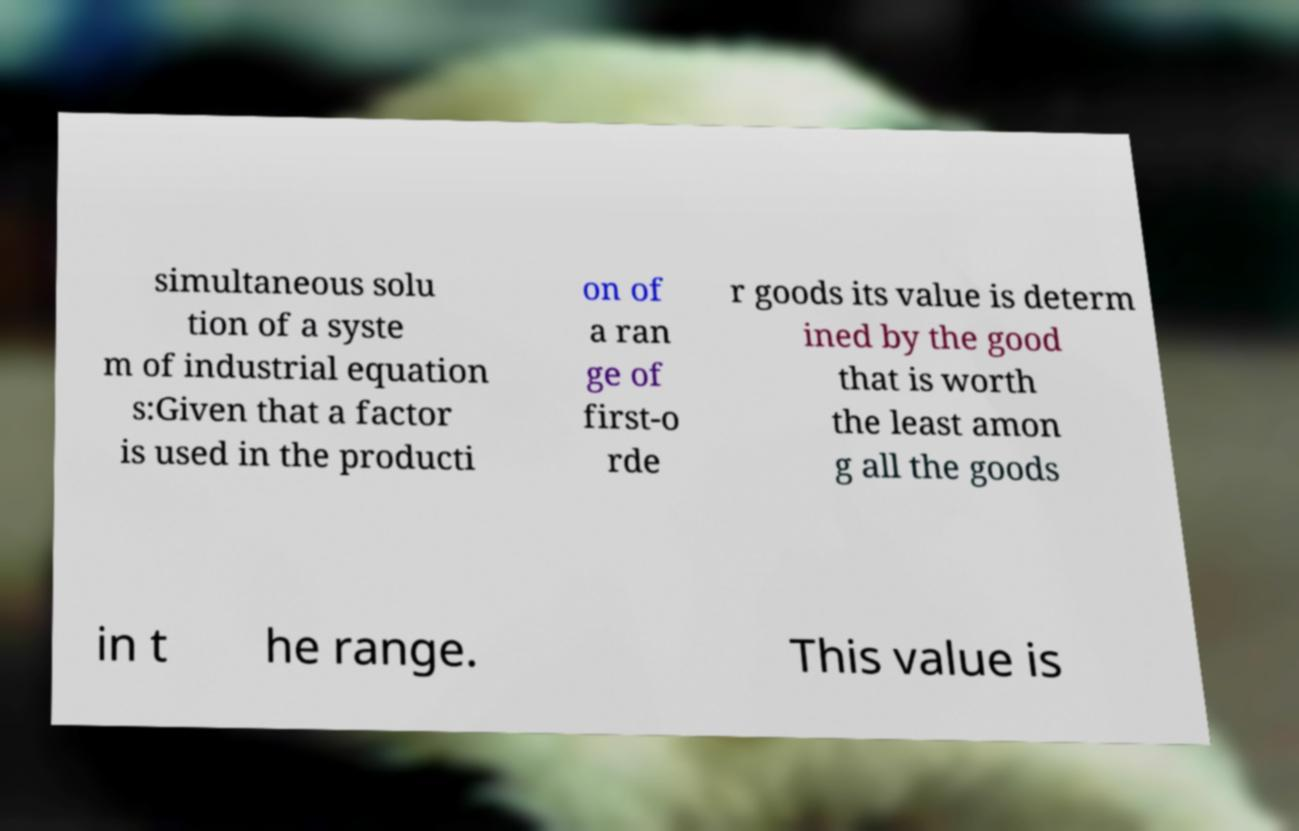I need the written content from this picture converted into text. Can you do that? simultaneous solu tion of a syste m of industrial equation s:Given that a factor is used in the producti on of a ran ge of first-o rde r goods its value is determ ined by the good that is worth the least amon g all the goods in t he range. This value is 